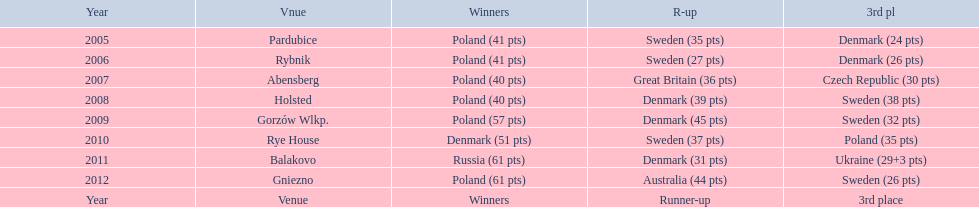Did holland win the 2010 championship? if not who did? Rye House. What did position did holland they rank? 3rd place. 